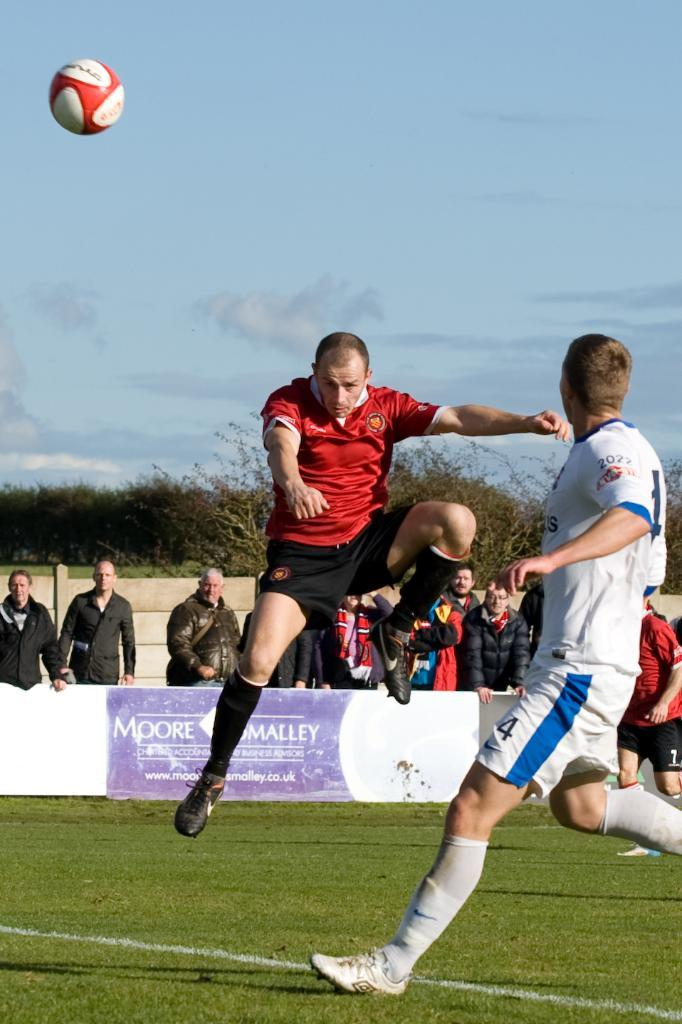<image>
Create a compact narrative representing the image presented. the word Moore is on the fence near the players 